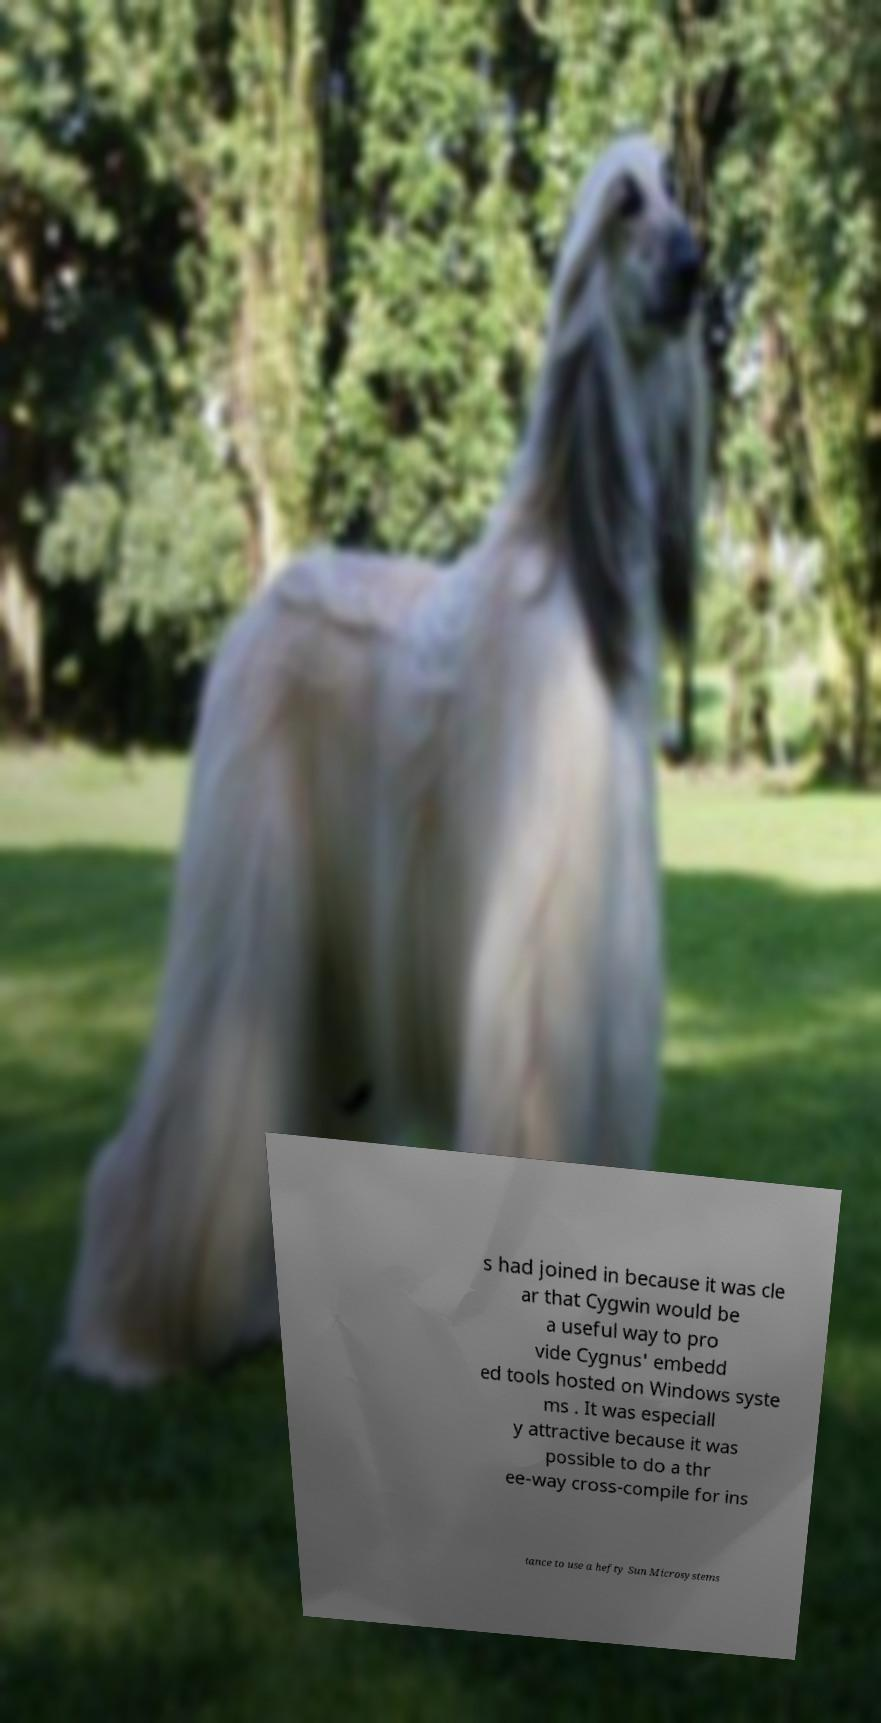Please identify and transcribe the text found in this image. s had joined in because it was cle ar that Cygwin would be a useful way to pro vide Cygnus' embedd ed tools hosted on Windows syste ms . It was especiall y attractive because it was possible to do a thr ee-way cross-compile for ins tance to use a hefty Sun Microsystems 